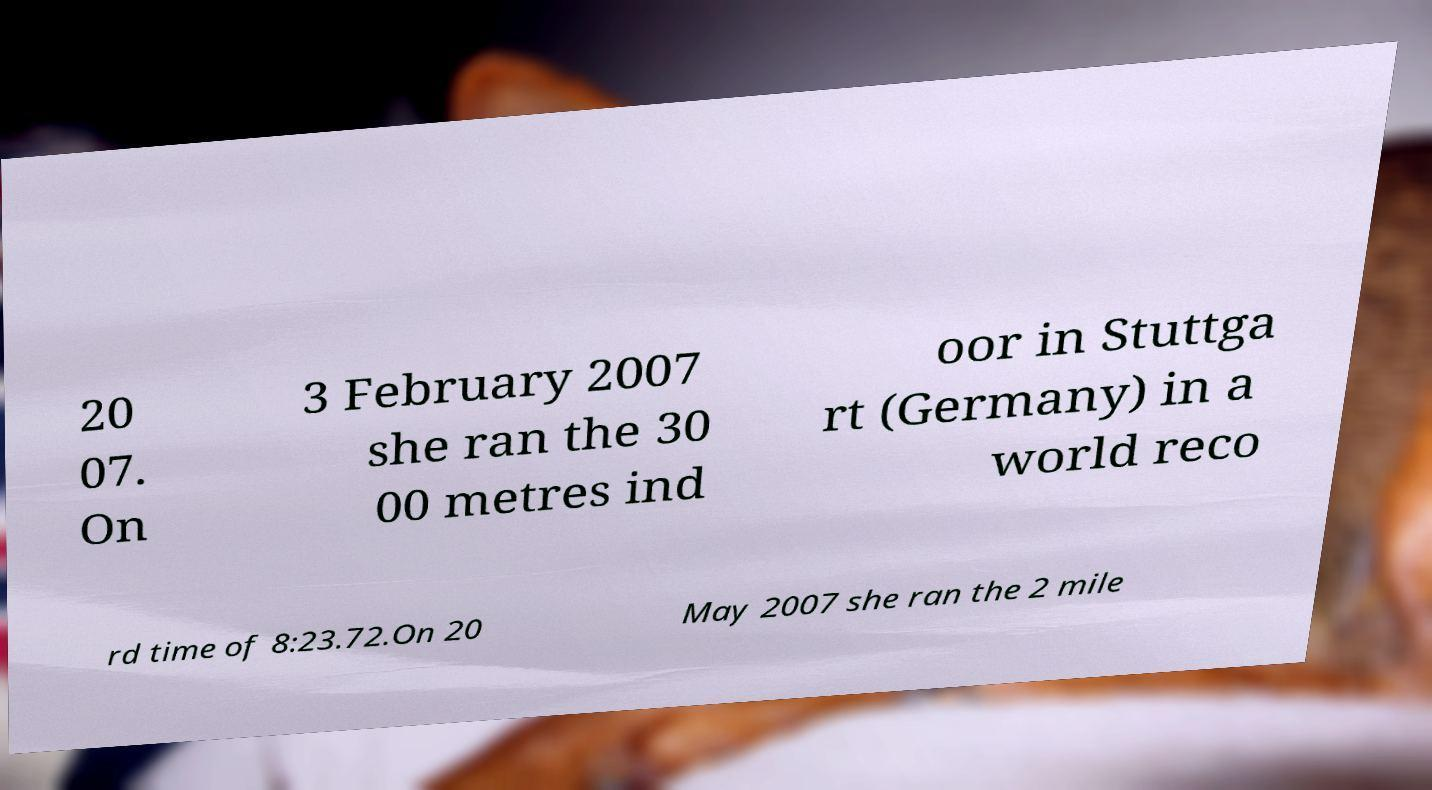Please read and relay the text visible in this image. What does it say? 20 07. On 3 February 2007 she ran the 30 00 metres ind oor in Stuttga rt (Germany) in a world reco rd time of 8:23.72.On 20 May 2007 she ran the 2 mile 